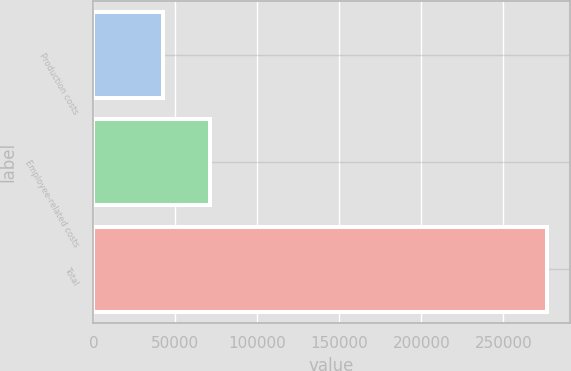Convert chart. <chart><loc_0><loc_0><loc_500><loc_500><bar_chart><fcel>Production costs<fcel>Employee-related costs<fcel>Total<nl><fcel>42772<fcel>71002<fcel>276809<nl></chart> 